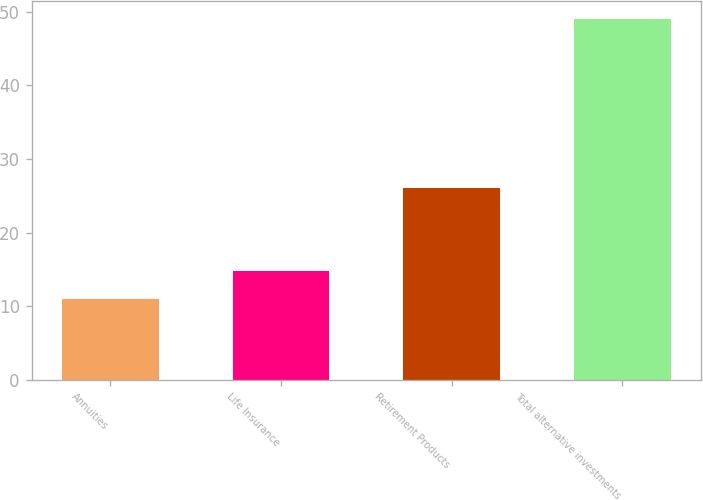<chart> <loc_0><loc_0><loc_500><loc_500><bar_chart><fcel>Annuities<fcel>Life Insurance<fcel>Retirement Products<fcel>Total alternative investments<nl><fcel>11<fcel>14.8<fcel>26<fcel>49<nl></chart> 